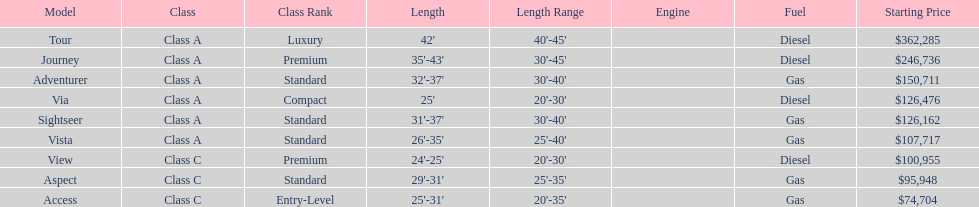What is the price of bot the via and tour models combined? $488,761. 